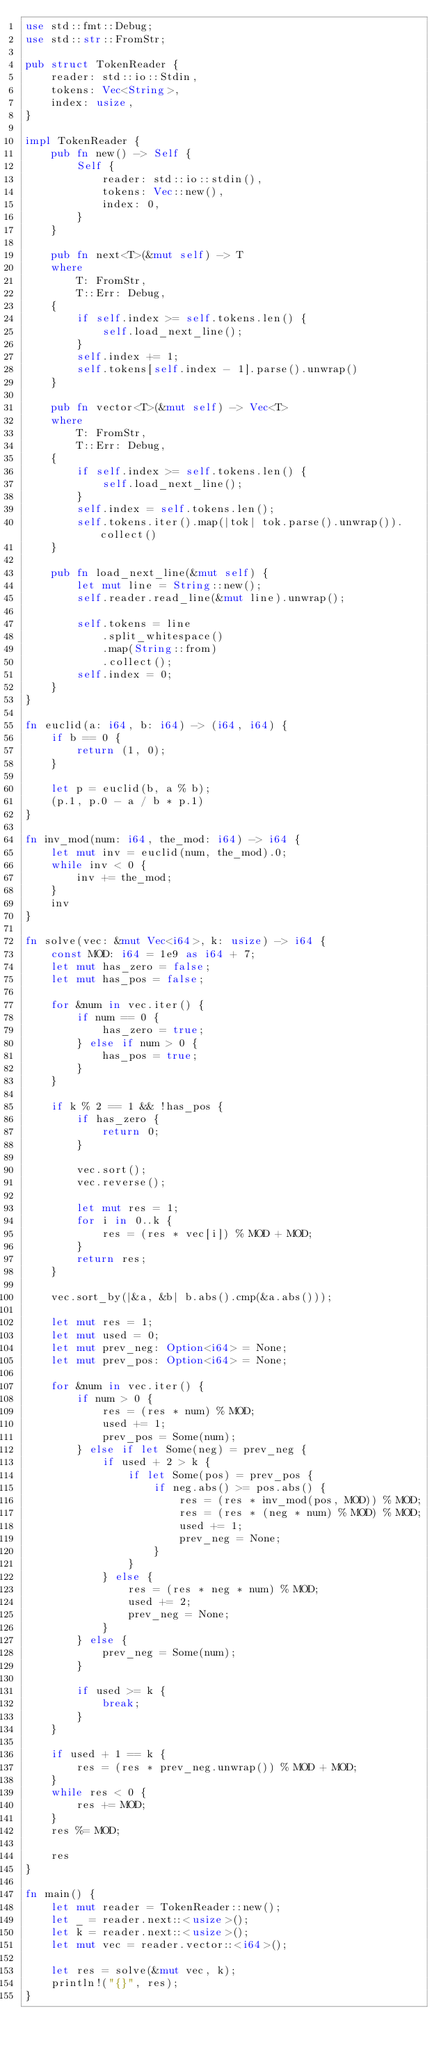<code> <loc_0><loc_0><loc_500><loc_500><_Rust_>use std::fmt::Debug;
use std::str::FromStr;

pub struct TokenReader {
    reader: std::io::Stdin,
    tokens: Vec<String>,
    index: usize,
}

impl TokenReader {
    pub fn new() -> Self {
        Self {
            reader: std::io::stdin(),
            tokens: Vec::new(),
            index: 0,
        }
    }

    pub fn next<T>(&mut self) -> T
    where
        T: FromStr,
        T::Err: Debug,
    {
        if self.index >= self.tokens.len() {
            self.load_next_line();
        }
        self.index += 1;
        self.tokens[self.index - 1].parse().unwrap()
    }

    pub fn vector<T>(&mut self) -> Vec<T>
    where
        T: FromStr,
        T::Err: Debug,
    {
        if self.index >= self.tokens.len() {
            self.load_next_line();
        }
        self.index = self.tokens.len();
        self.tokens.iter().map(|tok| tok.parse().unwrap()).collect()
    }

    pub fn load_next_line(&mut self) {
        let mut line = String::new();
        self.reader.read_line(&mut line).unwrap();

        self.tokens = line
            .split_whitespace()
            .map(String::from)
            .collect();
        self.index = 0;
    }
}

fn euclid(a: i64, b: i64) -> (i64, i64) {
    if b == 0 {
        return (1, 0);
    }

    let p = euclid(b, a % b);
    (p.1, p.0 - a / b * p.1)
}

fn inv_mod(num: i64, the_mod: i64) -> i64 {
    let mut inv = euclid(num, the_mod).0;
    while inv < 0 {
        inv += the_mod;
    }
    inv
}

fn solve(vec: &mut Vec<i64>, k: usize) -> i64 {
    const MOD: i64 = 1e9 as i64 + 7;
    let mut has_zero = false;
    let mut has_pos = false;

    for &num in vec.iter() {
        if num == 0 {
            has_zero = true;
        } else if num > 0 {
            has_pos = true;
        }
    }

    if k % 2 == 1 && !has_pos {
        if has_zero {
            return 0;
        }

        vec.sort();
        vec.reverse();

        let mut res = 1;
        for i in 0..k {
            res = (res * vec[i]) % MOD + MOD;
        }
        return res;
    }

    vec.sort_by(|&a, &b| b.abs().cmp(&a.abs()));

    let mut res = 1;
    let mut used = 0;
    let mut prev_neg: Option<i64> = None;
    let mut prev_pos: Option<i64> = None;

    for &num in vec.iter() {
        if num > 0 {
            res = (res * num) % MOD;
            used += 1;
            prev_pos = Some(num);
        } else if let Some(neg) = prev_neg {
            if used + 2 > k {
                if let Some(pos) = prev_pos {
                    if neg.abs() >= pos.abs() {
                        res = (res * inv_mod(pos, MOD)) % MOD;
                        res = (res * (neg * num) % MOD) % MOD;
                        used += 1;
                        prev_neg = None;
                    }
                }
            } else {
                res = (res * neg * num) % MOD;
                used += 2;
                prev_neg = None;
            }
        } else {
            prev_neg = Some(num);
        }

        if used >= k {
            break;
        }
    }

    if used + 1 == k {
        res = (res * prev_neg.unwrap()) % MOD + MOD;
    }
    while res < 0 {
        res += MOD;
    }
    res %= MOD;

    res
}

fn main() {
    let mut reader = TokenReader::new();
    let _ = reader.next::<usize>();
    let k = reader.next::<usize>();
    let mut vec = reader.vector::<i64>();

    let res = solve(&mut vec, k);
    println!("{}", res);
}
</code> 